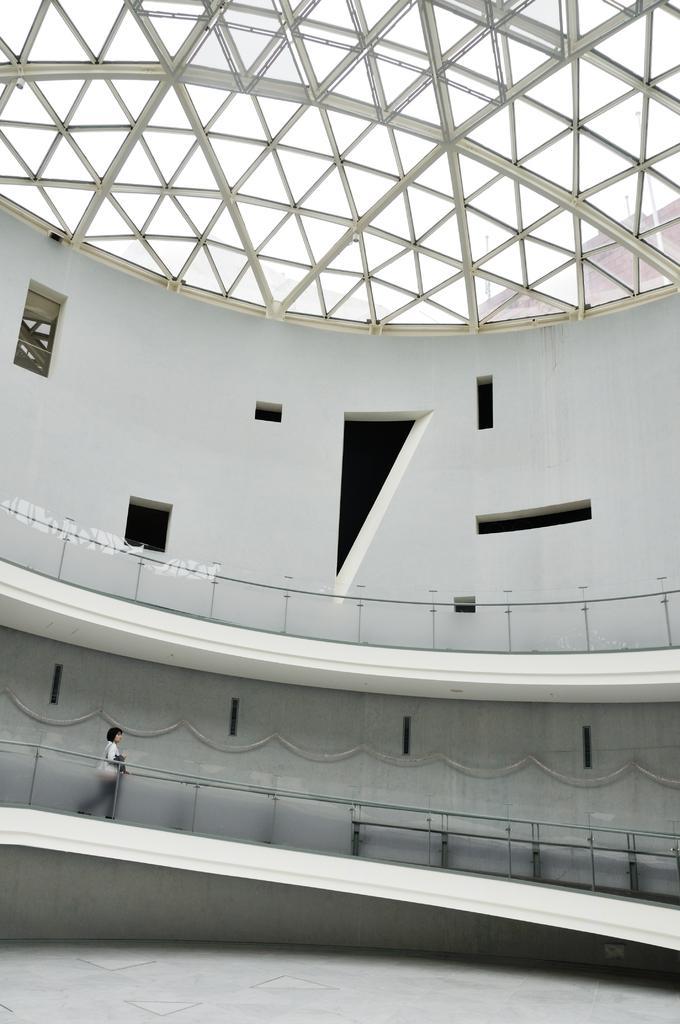Describe this image in one or two sentences. In the image we can see there is a woman standing on the ground and there is a building. 